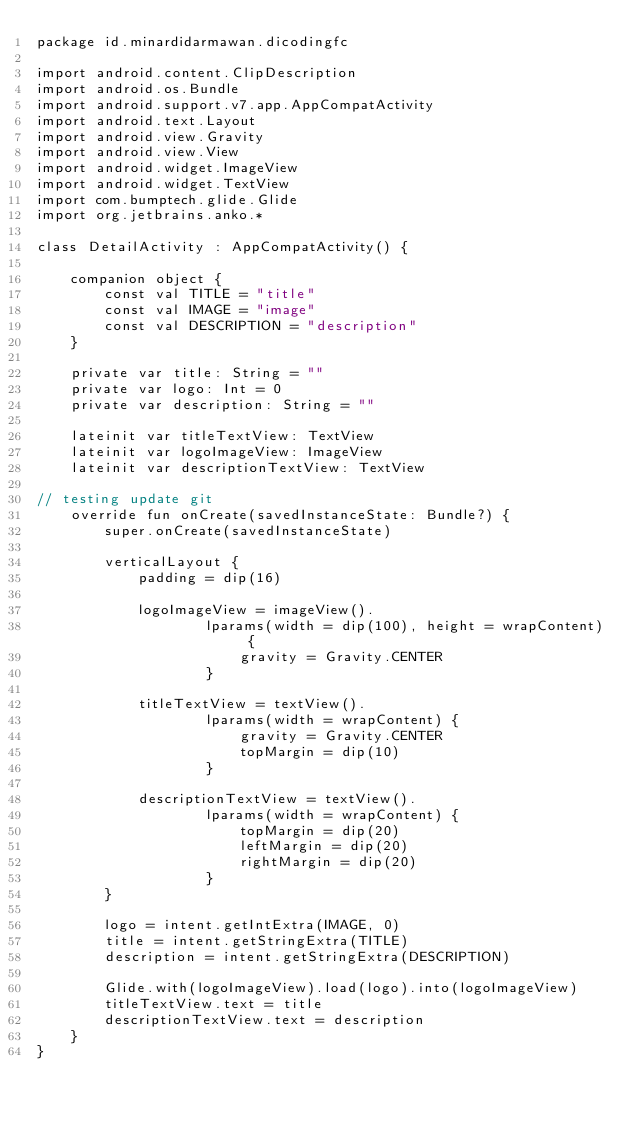<code> <loc_0><loc_0><loc_500><loc_500><_Kotlin_>package id.minardidarmawan.dicodingfc

import android.content.ClipDescription
import android.os.Bundle
import android.support.v7.app.AppCompatActivity
import android.text.Layout
import android.view.Gravity
import android.view.View
import android.widget.ImageView
import android.widget.TextView
import com.bumptech.glide.Glide
import org.jetbrains.anko.*

class DetailActivity : AppCompatActivity() {

    companion object {
        const val TITLE = "title"
        const val IMAGE = "image"
        const val DESCRIPTION = "description"
    }

    private var title: String = ""
    private var logo: Int = 0
    private var description: String = ""

    lateinit var titleTextView: TextView
    lateinit var logoImageView: ImageView
    lateinit var descriptionTextView: TextView

// testing update git
    override fun onCreate(savedInstanceState: Bundle?) {
        super.onCreate(savedInstanceState)

        verticalLayout {
            padding = dip(16)

            logoImageView = imageView().
                    lparams(width = dip(100), height = wrapContent) {
                        gravity = Gravity.CENTER
                    }

            titleTextView = textView().
                    lparams(width = wrapContent) {
                        gravity = Gravity.CENTER
                        topMargin = dip(10)
                    }

            descriptionTextView = textView().
                    lparams(width = wrapContent) {
                        topMargin = dip(20)
                        leftMargin = dip(20)
                        rightMargin = dip(20)
                    }
        }

        logo = intent.getIntExtra(IMAGE, 0)
        title = intent.getStringExtra(TITLE)
        description = intent.getStringExtra(DESCRIPTION)

        Glide.with(logoImageView).load(logo).into(logoImageView)
        titleTextView.text = title
        descriptionTextView.text = description
    }
}
</code> 